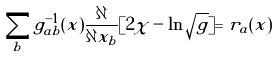<formula> <loc_0><loc_0><loc_500><loc_500>\sum _ { b } g ^ { - 1 } _ { a b } ( x ) \frac { \partial } { \partial x _ { b } } [ 2 \chi - \ln \sqrt { g } ] = r _ { a } ( x )</formula> 